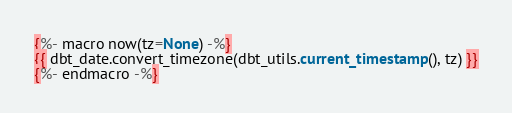<code> <loc_0><loc_0><loc_500><loc_500><_SQL_>{%- macro now(tz=None) -%}
{{ dbt_date.convert_timezone(dbt_utils.current_timestamp(), tz) }}
{%- endmacro -%}</code> 